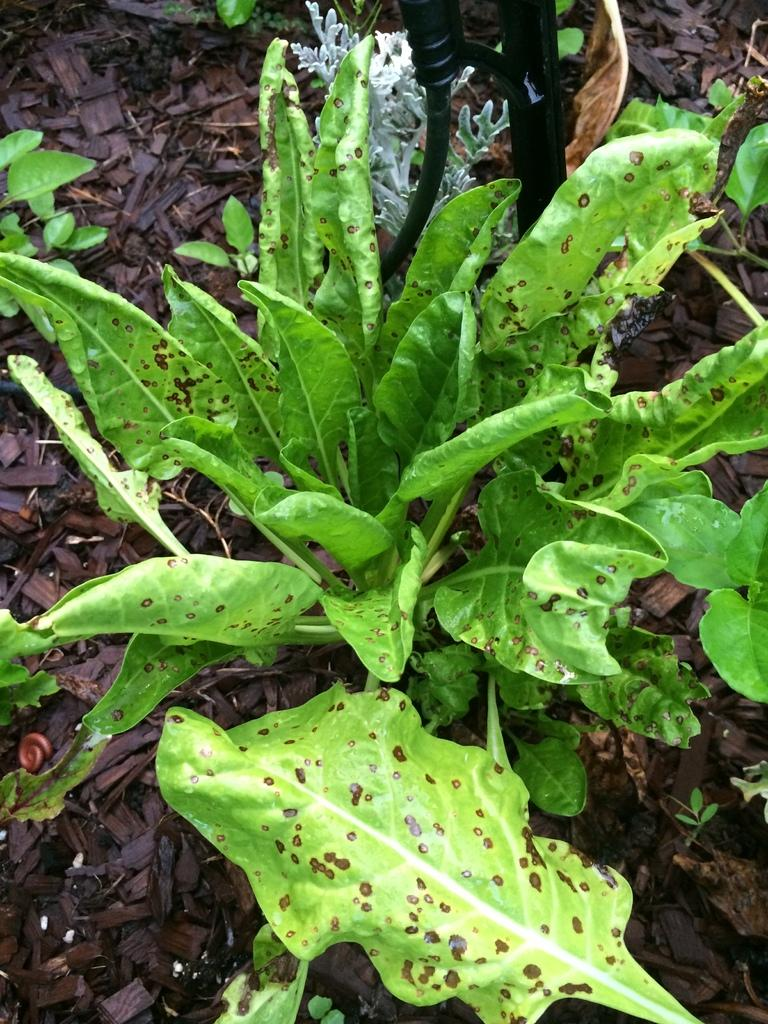What type of living organisms can be seen in the image? Plants can be seen in the image. What else is present in the image besides the plants? There is an object in the image. What can be found at the bottom of the image? Wooden sticks are present at the bottom of the image. What action is the son performing in the image? There is no son present in the image, so it is not possible to answer that question. 